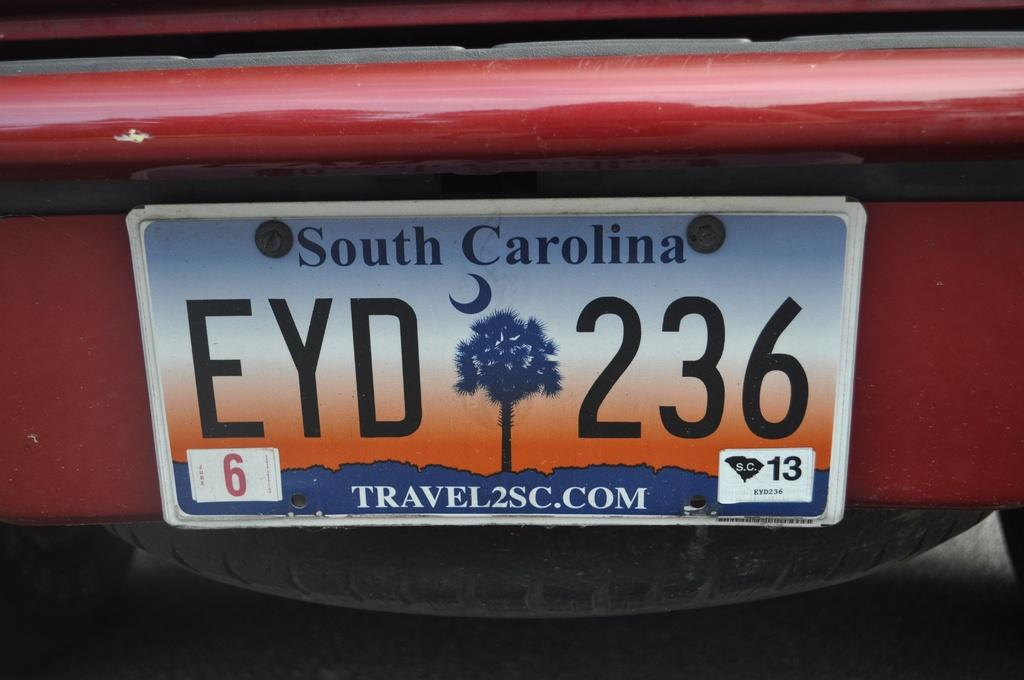Provide a one-sentence caption for the provided image. A south carolina license plate EYD 263 on a car. 